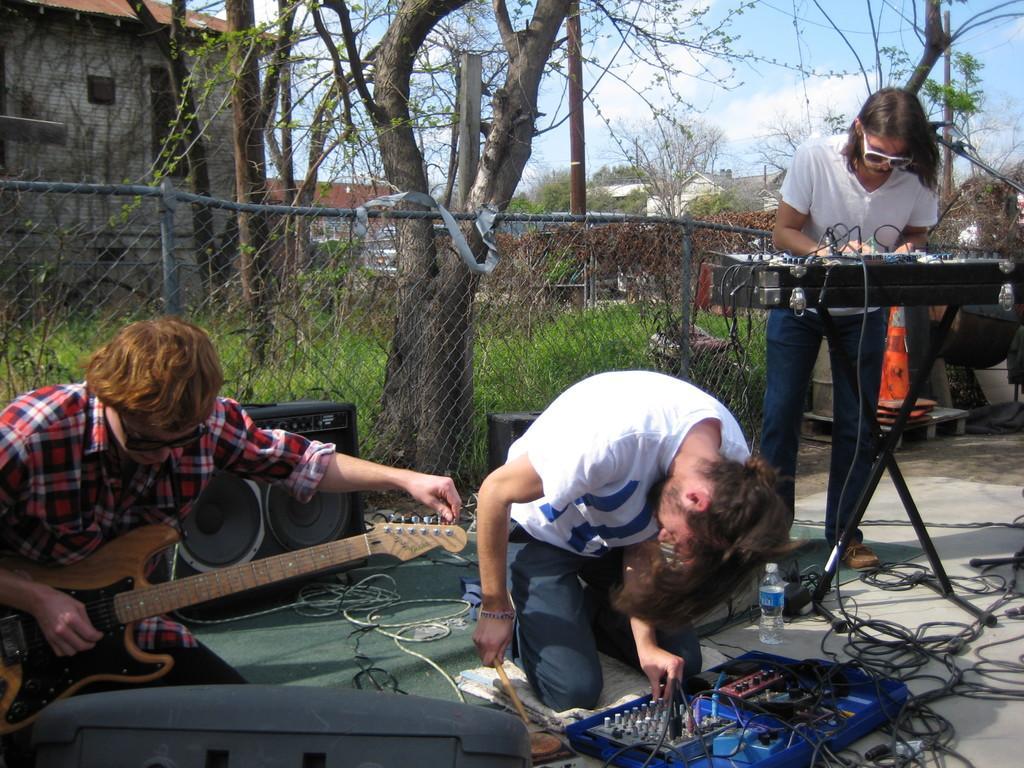In one or two sentences, can you explain what this image depicts? a person is sitting on his knees, holding a stick in his hand. left to him is a person guitar. right to him is a person playing keyboard. behind them there is a fencing. back of that there are trees. at the left corner there is a building. 